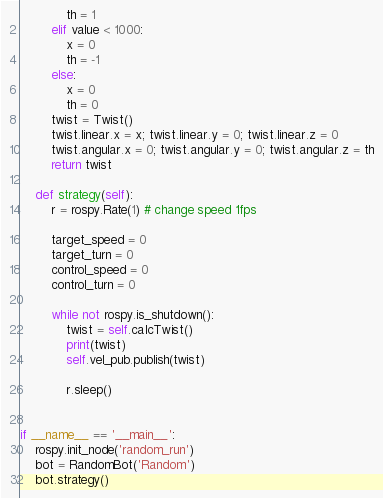Convert code to text. <code><loc_0><loc_0><loc_500><loc_500><_Python_>            th = 1
        elif value < 1000:
            x = 0
            th = -1
        else:
            x = 0
            th = 0
        twist = Twist()
        twist.linear.x = x; twist.linear.y = 0; twist.linear.z = 0
        twist.angular.x = 0; twist.angular.y = 0; twist.angular.z = th
        return twist

    def strategy(self):
        r = rospy.Rate(1) # change speed 1fps

        target_speed = 0
        target_turn = 0
        control_speed = 0
        control_turn = 0

        while not rospy.is_shutdown():
            twist = self.calcTwist()
            print(twist)
            self.vel_pub.publish(twist)

            r.sleep()


if __name__ == '__main__':
    rospy.init_node('random_run')
    bot = RandomBot('Random')
    bot.strategy()

</code> 